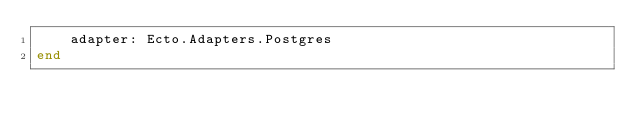<code> <loc_0><loc_0><loc_500><loc_500><_Elixir_>    adapter: Ecto.Adapters.Postgres
end
</code> 